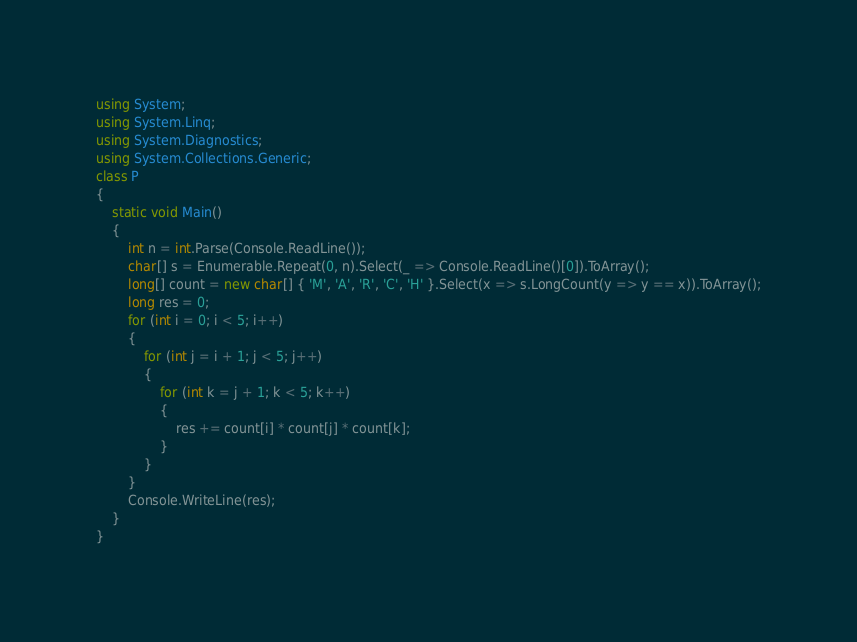Convert code to text. <code><loc_0><loc_0><loc_500><loc_500><_C#_>using System;
using System.Linq;
using System.Diagnostics;
using System.Collections.Generic;
class P
{
    static void Main()
    {
        int n = int.Parse(Console.ReadLine());
        char[] s = Enumerable.Repeat(0, n).Select(_ => Console.ReadLine()[0]).ToArray();
        long[] count = new char[] { 'M', 'A', 'R', 'C', 'H' }.Select(x => s.LongCount(y => y == x)).ToArray();
        long res = 0;
        for (int i = 0; i < 5; i++)
        {
            for (int j = i + 1; j < 5; j++)
            {
                for (int k = j + 1; k < 5; k++)
                {
                    res += count[i] * count[j] * count[k];
                }
            }
        }
        Console.WriteLine(res);
    }
}</code> 